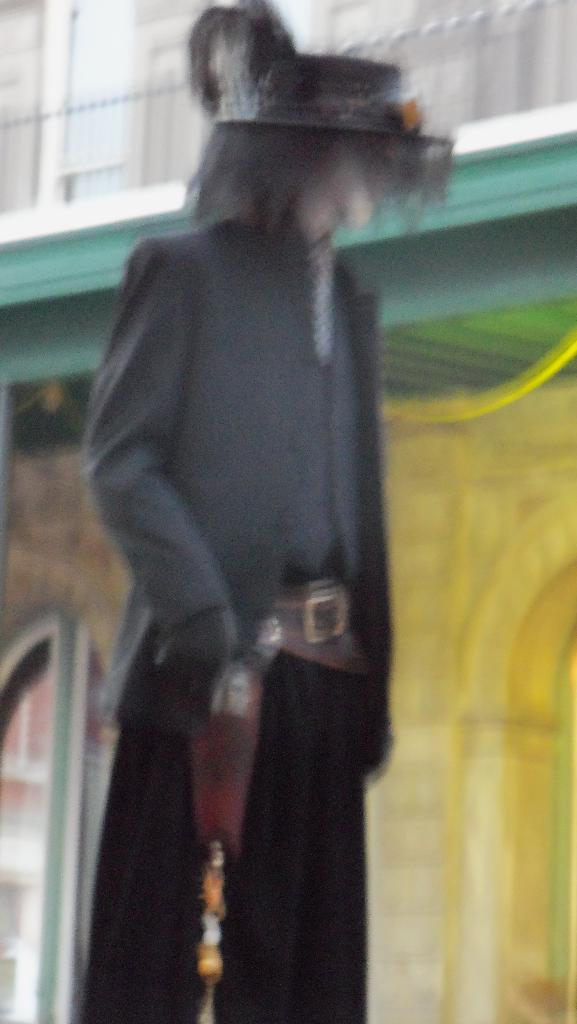What can be observed about the quality of the image in the picture? The image in the picture is blurry. How many beds are visible in the image? There are no beds present in the image, as it only features a blurry image. What type of transport is shown in the image? There is no transport visible in the image, as it only features a blurry image. 